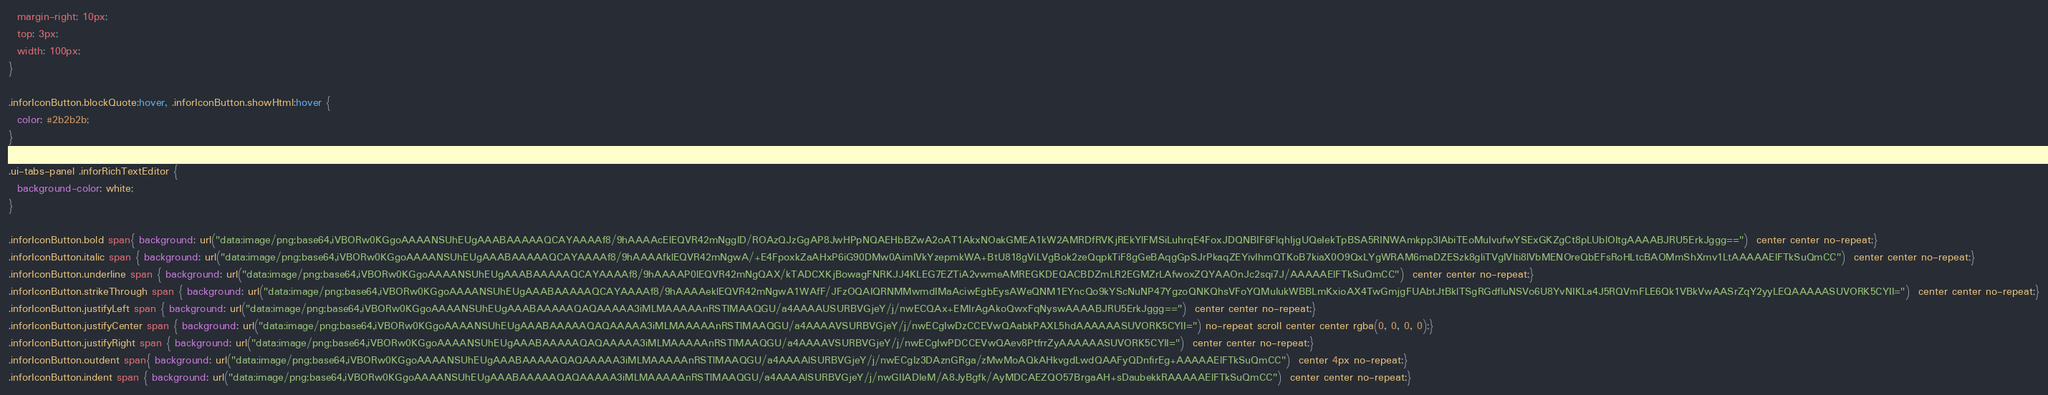Convert code to text. <code><loc_0><loc_0><loc_500><loc_500><_CSS_>  margin-right: 10px;
  top: 3px;
  width: 100px;
}

.inforIconButton.blockQuote:hover, .inforIconButton.showHtml:hover {
  color: #2b2b2b;
}

.ui-tabs-panel .inforRichTextEditor {
  background-color: white;
}

.inforIconButton.bold span{ background: url("data:image/png;base64,iVBORw0KGgoAAAANSUhEUgAAABAAAAAQCAYAAAAf8/9hAAAAcElEQVR42mNggID/ROAzQJzGgAP8JwHPpNQAEHbBZwA2oAT1AkxNOakGMEA1kW2AMRDfRVKjREkYlFMSiLuhrqE4FoxJDQNBIF6FlqhIjgUQeIekTpBSA5RINWAmkpp3lAbiTEoMuIvufwYSExGKZgCt8pLUblOItgAAAABJRU5ErkJggg==")  center center no-repeat;}
.inforIconButton.italic span { background: url("data:image/png;base64,iVBORw0KGgoAAAANSUhEUgAAABAAAAAQCAYAAAAf8/9hAAAAfklEQVR42mNgwA/+E4FpoxkZaAHxP6iG90DMw0AimIVkYzepmkWA+BtU818gViLVgBok2zeQqpkTiF8gGeBAqgGpSJrPkaqZEYivIhmQTKoB7kiaX0O9QxLYgWRAM6maDZESzk8gliTVgIVIti8lVbMENOreQbEFsRoHLtcBAOMmShXmv1LtAAAAAElFTkSuQmCC")  center center no-repeat;}
.inforIconButton.underline span { background: url("data:image/png;base64,iVBORw0KGgoAAAANSUhEUgAAABAAAAAQCAYAAAAf8/9hAAAAP0lEQVR42mNgQAX/kTADCXKjBowagFNRKJJ4KLEG7EZTiA2vwmeAMREGKDEQACBDZmLR2EGMZrLAfwoxZQYAAOnJc2sqi7J/AAAAAElFTkSuQmCC")  center center no-repeat;}
.inforIconButton.strikeThrough span { background: url("data:image/png;base64,iVBORw0KGgoAAAANSUhEUgAAABAAAAAQCAYAAAAf8/9hAAAAeklEQVR42mNgwA1WAfF/JFzOQAIQRNMMwmdIMaAciwEgbEysAWeQNM1EYncQo9kYScNuNP47YgzoQNKQhsVFoYQMuIukWBBLmKxioAX4TwGmjgFUAbtJtBklTSgRGdfluNSVo6U8YvNIKLa4J5RQVmFLE6Qk1VBkVwAASrZqY2yyLEQAAAAASUVORK5CYII=")  center center no-repeat;}
.inforIconButton.justifyLeft span { background: url("data:image/png;base64,iVBORw0KGgoAAAANSUhEUgAAABAAAAAQAQAAAAA3iMLMAAAAAnRSTlMAAQGU/a4AAAAUSURBVGjeY/j/nwECQAx+EMIrAgAkoQwxFqNyswAAAABJRU5ErkJggg==")  center center no-repeat;}
.inforIconButton.justifyCenter span { background: url("data:image/png;base64,iVBORw0KGgoAAAANSUhEUgAAABAAAAAQAQAAAAA3iMLMAAAAAnRSTlMAAQGU/a4AAAAVSURBVGjeY/j/nwECgIwDzCCEVwQAabkPAXL5hdAAAAAASUVORK5CYII=") no-repeat scroll center center rgba(0, 0, 0, 0);}
.inforIconButton.justifyRight span { background: url("data:image/png;base64,iVBORw0KGgoAAAANSUhEUgAAABAAAAAQAQAAAAA3iMLMAAAAAnRSTlMAAQGU/a4AAAAVSURBVGjeY/j/nwECgIwPDCCEVwQAev8PtfrrZyAAAAAASUVORK5CYII=")  center center no-repeat;}
.inforIconButton.outdent span{ background: url("data:image/png;base64,iVBORw0KGgoAAAANSUhEUgAAABAAAAAQAQAAAAA3iMLMAAAAAnRSTlMAAQGU/a4AAAAlSURBVGjeY/j/nwECgIz3DAznGRga/zMwMoAQkAHkvgdLwdQAAFyQDnfirEg+AAAAAElFTkSuQmCC")  center 4px no-repeat;}
.inforIconButton.indent span { background: url("data:image/png;base64,iVBORw0KGgoAAAANSUhEUgAAABAAAAAQAQAAAAA3iMLMAAAAAnRSTlMAAQGU/a4AAAAlSURBVGjeY/j/nwGIIADIeM/A8JyBgfk/AyMDCAEZQO57BrgaAH+sDaubekkRAAAAAElFTkSuQmCC")  center center no-repeat;}</code> 